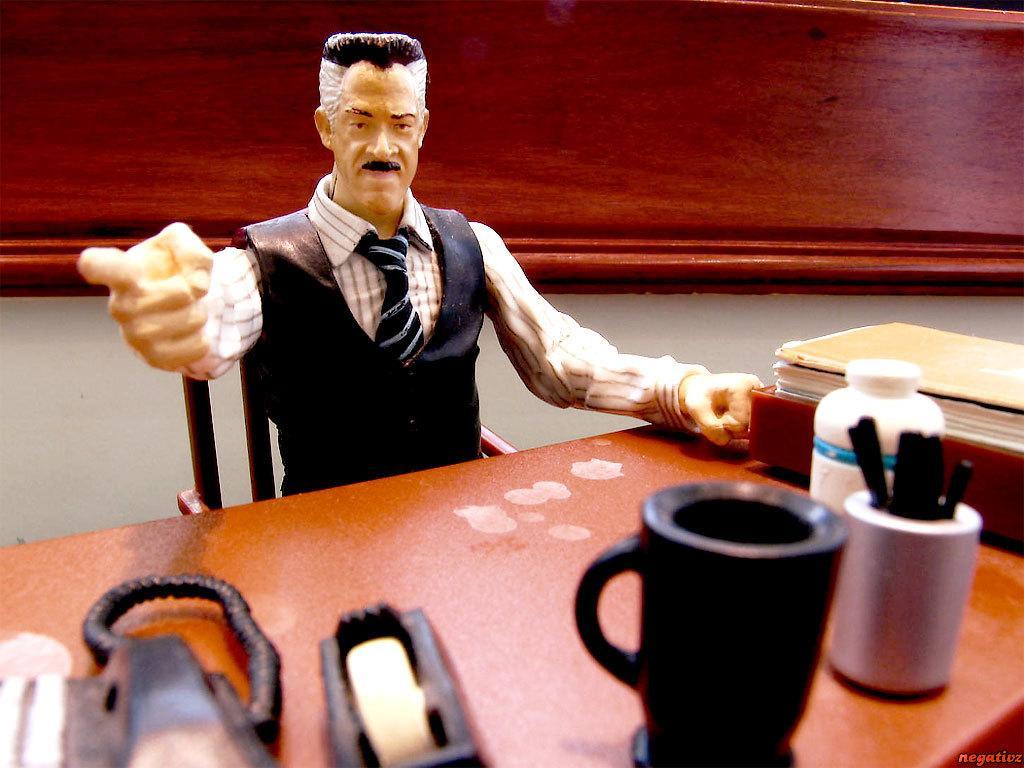How would you summarize this image in a sentence or two? In the middle of the image a man is sitting on a chair. In front of him there is a table on the table there is a cup, pens and pen holder, bottle, books and there are some products on the table. Behind him there is a wall. 